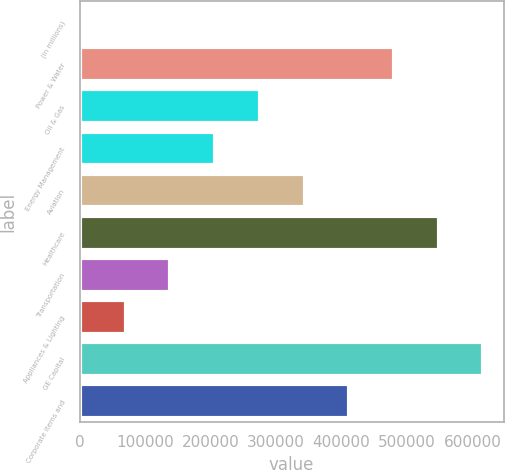<chart> <loc_0><loc_0><loc_500><loc_500><bar_chart><fcel>(In millions)<fcel>Power & Water<fcel>Oil & Gas<fcel>Energy Management<fcel>Aviation<fcel>Healthcare<fcel>Transportation<fcel>Appliances & Lighting<fcel>GE Capital<fcel>Corporate items and<nl><fcel>2012<fcel>480103<fcel>275207<fcel>206908<fcel>343506<fcel>548402<fcel>138609<fcel>70310.7<fcel>616700<fcel>411804<nl></chart> 